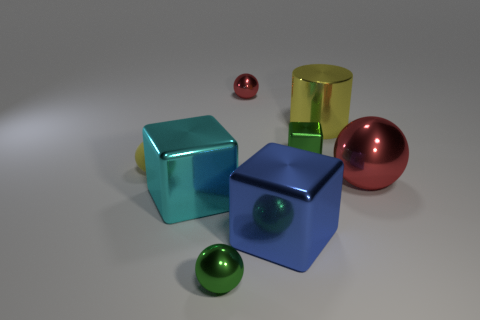The cylinder that is the same color as the tiny matte ball is what size?
Ensure brevity in your answer.  Large. Is there another blue rubber ball of the same size as the matte ball?
Your response must be concise. No. Does the large blue cube have the same material as the small object that is in front of the blue thing?
Your answer should be compact. Yes. Are there more small yellow metal objects than shiny things?
Offer a very short reply. No. How many cylinders are either tiny green objects or yellow shiny objects?
Make the answer very short. 1. The tiny rubber ball has what color?
Your answer should be compact. Yellow. Do the metallic ball that is behind the yellow rubber thing and the red object that is to the right of the tiny red ball have the same size?
Ensure brevity in your answer.  No. Is the number of metal things less than the number of big shiny cylinders?
Your answer should be compact. No. What number of red objects are in front of the tiny shiny cube?
Your answer should be compact. 1. What material is the green block?
Give a very brief answer. Metal. 